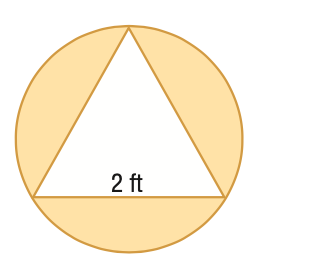Answer the mathemtical geometry problem and directly provide the correct option letter.
Question: Find the area of the shaded region formed by the circle and regular polygon. Round to the nearest tenth.
Choices: A: 0.7 B: 2.5 C: 6.6 D: 15.0 B 